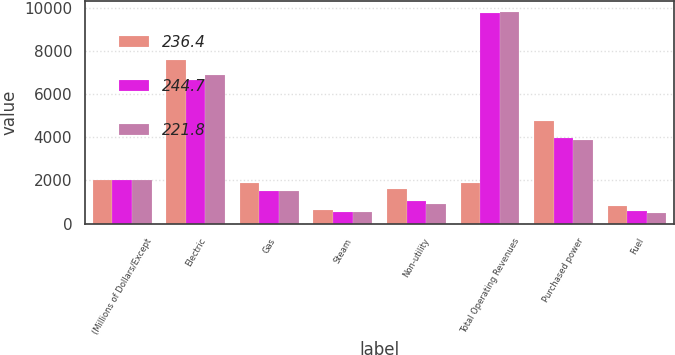Convert chart to OTSL. <chart><loc_0><loc_0><loc_500><loc_500><stacked_bar_chart><ecel><fcel>(Millions of Dollars/Except<fcel>Electric<fcel>Gas<fcel>Steam<fcel>Non-utility<fcel>Total Operating Revenues<fcel>Purchased power<fcel>Fuel<nl><fcel>236.4<fcel>2005<fcel>7588<fcel>1858<fcel>649<fcel>1595<fcel>1858<fcel>4743<fcel>816<nl><fcel>244.7<fcel>2004<fcel>6652<fcel>1507<fcel>550<fcel>1049<fcel>9758<fcel>3960<fcel>597<nl><fcel>221.8<fcel>2003<fcel>6863<fcel>1492<fcel>537<fcel>916<fcel>9808<fcel>3884<fcel>504<nl></chart> 